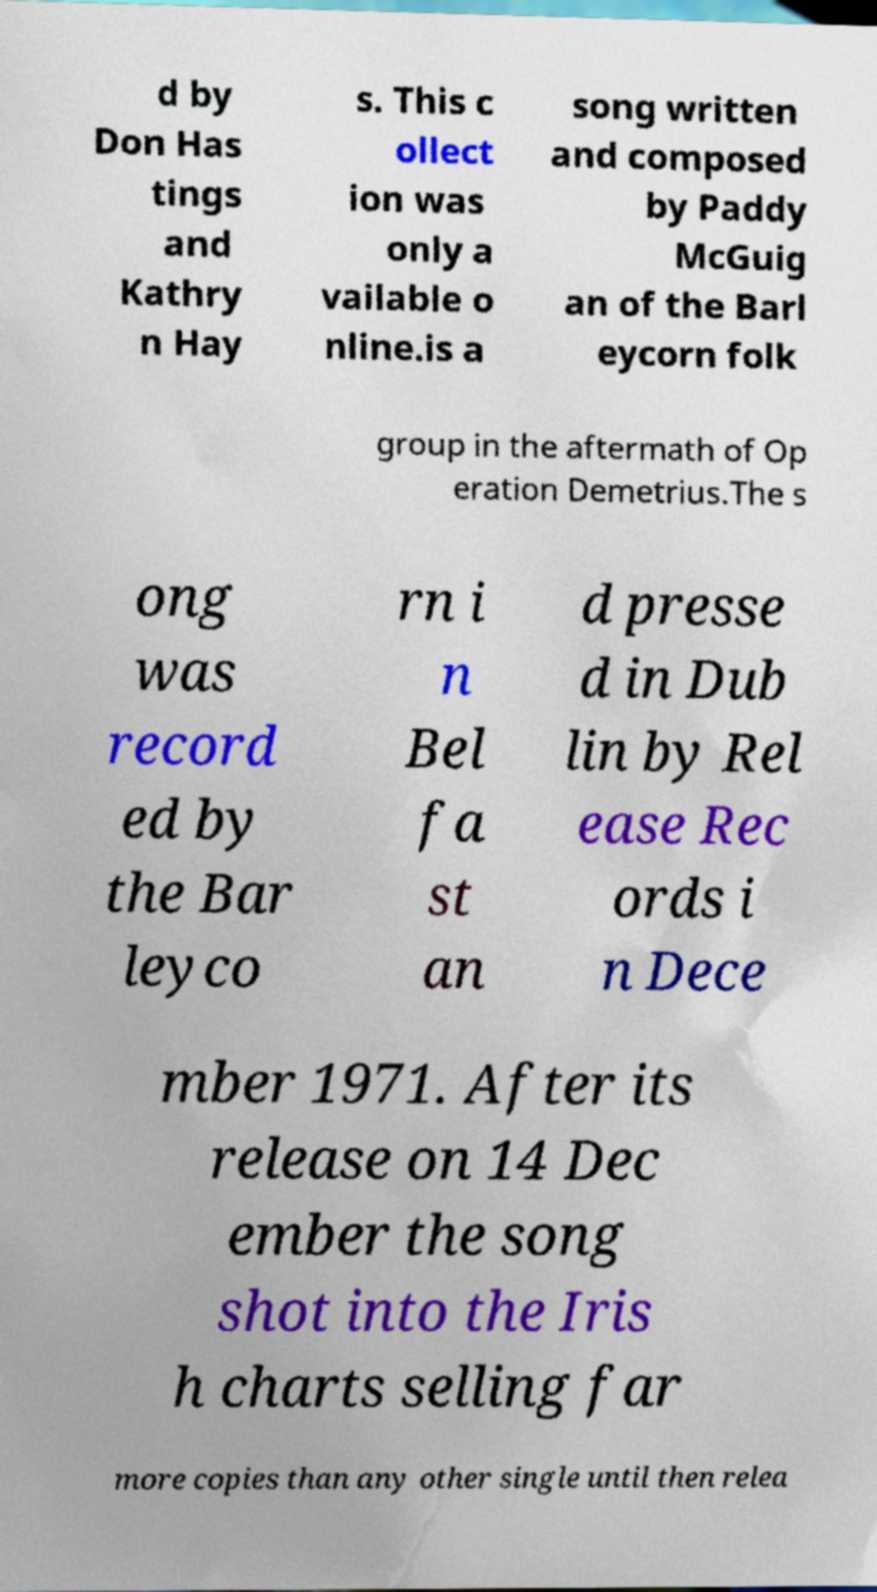What messages or text are displayed in this image? I need them in a readable, typed format. d by Don Has tings and Kathry n Hay s. This c ollect ion was only a vailable o nline.is a song written and composed by Paddy McGuig an of the Barl eycorn folk group in the aftermath of Op eration Demetrius.The s ong was record ed by the Bar leyco rn i n Bel fa st an d presse d in Dub lin by Rel ease Rec ords i n Dece mber 1971. After its release on 14 Dec ember the song shot into the Iris h charts selling far more copies than any other single until then relea 